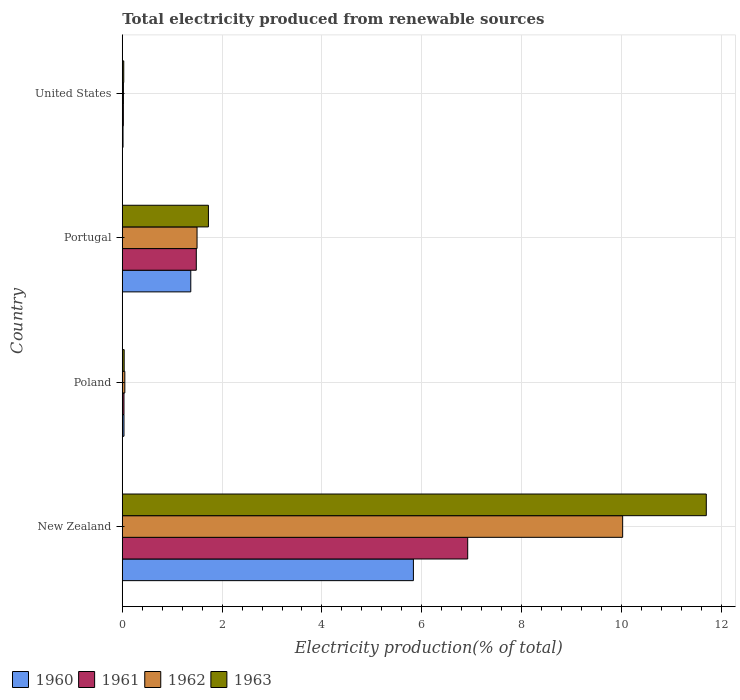How many different coloured bars are there?
Your response must be concise. 4. Are the number of bars per tick equal to the number of legend labels?
Give a very brief answer. Yes. How many bars are there on the 1st tick from the top?
Make the answer very short. 4. How many bars are there on the 1st tick from the bottom?
Your response must be concise. 4. What is the label of the 4th group of bars from the top?
Ensure brevity in your answer.  New Zealand. In how many cases, is the number of bars for a given country not equal to the number of legend labels?
Keep it short and to the point. 0. What is the total electricity produced in 1960 in Poland?
Provide a short and direct response. 0.03. Across all countries, what is the maximum total electricity produced in 1960?
Make the answer very short. 5.83. Across all countries, what is the minimum total electricity produced in 1961?
Provide a succinct answer. 0.02. In which country was the total electricity produced in 1960 maximum?
Your response must be concise. New Zealand. In which country was the total electricity produced in 1961 minimum?
Make the answer very short. United States. What is the total total electricity produced in 1963 in the graph?
Provide a succinct answer. 13.49. What is the difference between the total electricity produced in 1963 in New Zealand and that in Poland?
Your answer should be very brief. 11.66. What is the difference between the total electricity produced in 1962 in United States and the total electricity produced in 1961 in New Zealand?
Provide a succinct answer. -6.9. What is the average total electricity produced in 1962 per country?
Your response must be concise. 2.9. What is the difference between the total electricity produced in 1963 and total electricity produced in 1962 in Poland?
Provide a short and direct response. -0.01. In how many countries, is the total electricity produced in 1962 greater than 0.4 %?
Make the answer very short. 2. What is the ratio of the total electricity produced in 1961 in New Zealand to that in Poland?
Your response must be concise. 202.83. What is the difference between the highest and the second highest total electricity produced in 1960?
Offer a very short reply. 4.46. What is the difference between the highest and the lowest total electricity produced in 1960?
Your answer should be compact. 5.82. In how many countries, is the total electricity produced in 1962 greater than the average total electricity produced in 1962 taken over all countries?
Your answer should be compact. 1. Is it the case that in every country, the sum of the total electricity produced in 1960 and total electricity produced in 1962 is greater than the sum of total electricity produced in 1961 and total electricity produced in 1963?
Provide a succinct answer. No. What does the 3rd bar from the bottom in New Zealand represents?
Your response must be concise. 1962. How many bars are there?
Provide a short and direct response. 16. Are all the bars in the graph horizontal?
Offer a terse response. Yes. How many countries are there in the graph?
Provide a short and direct response. 4. Does the graph contain any zero values?
Your response must be concise. No. Where does the legend appear in the graph?
Your response must be concise. Bottom left. How many legend labels are there?
Ensure brevity in your answer.  4. How are the legend labels stacked?
Make the answer very short. Horizontal. What is the title of the graph?
Offer a very short reply. Total electricity produced from renewable sources. What is the Electricity production(% of total) in 1960 in New Zealand?
Provide a short and direct response. 5.83. What is the Electricity production(% of total) in 1961 in New Zealand?
Offer a terse response. 6.92. What is the Electricity production(% of total) of 1962 in New Zealand?
Provide a short and direct response. 10.02. What is the Electricity production(% of total) of 1963 in New Zealand?
Provide a short and direct response. 11.7. What is the Electricity production(% of total) in 1960 in Poland?
Ensure brevity in your answer.  0.03. What is the Electricity production(% of total) in 1961 in Poland?
Provide a short and direct response. 0.03. What is the Electricity production(% of total) of 1962 in Poland?
Offer a very short reply. 0.05. What is the Electricity production(% of total) of 1963 in Poland?
Your answer should be compact. 0.04. What is the Electricity production(% of total) of 1960 in Portugal?
Your response must be concise. 1.37. What is the Electricity production(% of total) of 1961 in Portugal?
Offer a terse response. 1.48. What is the Electricity production(% of total) in 1962 in Portugal?
Make the answer very short. 1.5. What is the Electricity production(% of total) of 1963 in Portugal?
Ensure brevity in your answer.  1.73. What is the Electricity production(% of total) in 1960 in United States?
Offer a terse response. 0.02. What is the Electricity production(% of total) of 1961 in United States?
Give a very brief answer. 0.02. What is the Electricity production(% of total) of 1962 in United States?
Offer a terse response. 0.02. What is the Electricity production(% of total) in 1963 in United States?
Make the answer very short. 0.03. Across all countries, what is the maximum Electricity production(% of total) of 1960?
Ensure brevity in your answer.  5.83. Across all countries, what is the maximum Electricity production(% of total) in 1961?
Your response must be concise. 6.92. Across all countries, what is the maximum Electricity production(% of total) of 1962?
Offer a very short reply. 10.02. Across all countries, what is the maximum Electricity production(% of total) in 1963?
Keep it short and to the point. 11.7. Across all countries, what is the minimum Electricity production(% of total) of 1960?
Your answer should be very brief. 0.02. Across all countries, what is the minimum Electricity production(% of total) in 1961?
Provide a short and direct response. 0.02. Across all countries, what is the minimum Electricity production(% of total) of 1962?
Give a very brief answer. 0.02. Across all countries, what is the minimum Electricity production(% of total) in 1963?
Offer a terse response. 0.03. What is the total Electricity production(% of total) of 1960 in the graph?
Your answer should be very brief. 7.25. What is the total Electricity production(% of total) of 1961 in the graph?
Your response must be concise. 8.46. What is the total Electricity production(% of total) in 1962 in the graph?
Your response must be concise. 11.6. What is the total Electricity production(% of total) in 1963 in the graph?
Provide a succinct answer. 13.49. What is the difference between the Electricity production(% of total) in 1960 in New Zealand and that in Poland?
Give a very brief answer. 5.8. What is the difference between the Electricity production(% of total) in 1961 in New Zealand and that in Poland?
Make the answer very short. 6.89. What is the difference between the Electricity production(% of total) of 1962 in New Zealand and that in Poland?
Offer a very short reply. 9.97. What is the difference between the Electricity production(% of total) of 1963 in New Zealand and that in Poland?
Keep it short and to the point. 11.66. What is the difference between the Electricity production(% of total) of 1960 in New Zealand and that in Portugal?
Your answer should be very brief. 4.46. What is the difference between the Electricity production(% of total) in 1961 in New Zealand and that in Portugal?
Keep it short and to the point. 5.44. What is the difference between the Electricity production(% of total) in 1962 in New Zealand and that in Portugal?
Keep it short and to the point. 8.53. What is the difference between the Electricity production(% of total) in 1963 in New Zealand and that in Portugal?
Offer a very short reply. 9.97. What is the difference between the Electricity production(% of total) in 1960 in New Zealand and that in United States?
Your answer should be very brief. 5.82. What is the difference between the Electricity production(% of total) in 1961 in New Zealand and that in United States?
Ensure brevity in your answer.  6.9. What is the difference between the Electricity production(% of total) in 1962 in New Zealand and that in United States?
Provide a succinct answer. 10. What is the difference between the Electricity production(% of total) in 1963 in New Zealand and that in United States?
Provide a succinct answer. 11.67. What is the difference between the Electricity production(% of total) in 1960 in Poland and that in Portugal?
Provide a succinct answer. -1.34. What is the difference between the Electricity production(% of total) of 1961 in Poland and that in Portugal?
Your answer should be compact. -1.45. What is the difference between the Electricity production(% of total) in 1962 in Poland and that in Portugal?
Give a very brief answer. -1.45. What is the difference between the Electricity production(% of total) of 1963 in Poland and that in Portugal?
Offer a very short reply. -1.69. What is the difference between the Electricity production(% of total) in 1960 in Poland and that in United States?
Ensure brevity in your answer.  0.02. What is the difference between the Electricity production(% of total) in 1961 in Poland and that in United States?
Your response must be concise. 0.01. What is the difference between the Electricity production(% of total) of 1962 in Poland and that in United States?
Your response must be concise. 0.03. What is the difference between the Electricity production(% of total) of 1963 in Poland and that in United States?
Provide a succinct answer. 0.01. What is the difference between the Electricity production(% of total) in 1960 in Portugal and that in United States?
Offer a very short reply. 1.36. What is the difference between the Electricity production(% of total) in 1961 in Portugal and that in United States?
Your answer should be compact. 1.46. What is the difference between the Electricity production(% of total) of 1962 in Portugal and that in United States?
Provide a short and direct response. 1.48. What is the difference between the Electricity production(% of total) of 1963 in Portugal and that in United States?
Keep it short and to the point. 1.7. What is the difference between the Electricity production(% of total) in 1960 in New Zealand and the Electricity production(% of total) in 1961 in Poland?
Provide a short and direct response. 5.8. What is the difference between the Electricity production(% of total) in 1960 in New Zealand and the Electricity production(% of total) in 1962 in Poland?
Give a very brief answer. 5.78. What is the difference between the Electricity production(% of total) of 1960 in New Zealand and the Electricity production(% of total) of 1963 in Poland?
Offer a very short reply. 5.79. What is the difference between the Electricity production(% of total) of 1961 in New Zealand and the Electricity production(% of total) of 1962 in Poland?
Keep it short and to the point. 6.87. What is the difference between the Electricity production(% of total) of 1961 in New Zealand and the Electricity production(% of total) of 1963 in Poland?
Your response must be concise. 6.88. What is the difference between the Electricity production(% of total) in 1962 in New Zealand and the Electricity production(% of total) in 1963 in Poland?
Your answer should be very brief. 9.99. What is the difference between the Electricity production(% of total) of 1960 in New Zealand and the Electricity production(% of total) of 1961 in Portugal?
Make the answer very short. 4.35. What is the difference between the Electricity production(% of total) in 1960 in New Zealand and the Electricity production(% of total) in 1962 in Portugal?
Make the answer very short. 4.33. What is the difference between the Electricity production(% of total) in 1960 in New Zealand and the Electricity production(% of total) in 1963 in Portugal?
Provide a succinct answer. 4.11. What is the difference between the Electricity production(% of total) of 1961 in New Zealand and the Electricity production(% of total) of 1962 in Portugal?
Give a very brief answer. 5.42. What is the difference between the Electricity production(% of total) in 1961 in New Zealand and the Electricity production(% of total) in 1963 in Portugal?
Your answer should be very brief. 5.19. What is the difference between the Electricity production(% of total) in 1962 in New Zealand and the Electricity production(% of total) in 1963 in Portugal?
Provide a succinct answer. 8.3. What is the difference between the Electricity production(% of total) of 1960 in New Zealand and the Electricity production(% of total) of 1961 in United States?
Give a very brief answer. 5.81. What is the difference between the Electricity production(% of total) in 1960 in New Zealand and the Electricity production(% of total) in 1962 in United States?
Make the answer very short. 5.81. What is the difference between the Electricity production(% of total) of 1960 in New Zealand and the Electricity production(% of total) of 1963 in United States?
Provide a succinct answer. 5.8. What is the difference between the Electricity production(% of total) in 1961 in New Zealand and the Electricity production(% of total) in 1962 in United States?
Offer a terse response. 6.9. What is the difference between the Electricity production(% of total) of 1961 in New Zealand and the Electricity production(% of total) of 1963 in United States?
Offer a terse response. 6.89. What is the difference between the Electricity production(% of total) in 1962 in New Zealand and the Electricity production(% of total) in 1963 in United States?
Give a very brief answer. 10. What is the difference between the Electricity production(% of total) in 1960 in Poland and the Electricity production(% of total) in 1961 in Portugal?
Make the answer very short. -1.45. What is the difference between the Electricity production(% of total) of 1960 in Poland and the Electricity production(% of total) of 1962 in Portugal?
Provide a short and direct response. -1.46. What is the difference between the Electricity production(% of total) in 1960 in Poland and the Electricity production(% of total) in 1963 in Portugal?
Keep it short and to the point. -1.69. What is the difference between the Electricity production(% of total) of 1961 in Poland and the Electricity production(% of total) of 1962 in Portugal?
Offer a terse response. -1.46. What is the difference between the Electricity production(% of total) of 1961 in Poland and the Electricity production(% of total) of 1963 in Portugal?
Your response must be concise. -1.69. What is the difference between the Electricity production(% of total) of 1962 in Poland and the Electricity production(% of total) of 1963 in Portugal?
Offer a very short reply. -1.67. What is the difference between the Electricity production(% of total) of 1960 in Poland and the Electricity production(% of total) of 1961 in United States?
Offer a very short reply. 0.01. What is the difference between the Electricity production(% of total) in 1960 in Poland and the Electricity production(% of total) in 1962 in United States?
Give a very brief answer. 0.01. What is the difference between the Electricity production(% of total) of 1960 in Poland and the Electricity production(% of total) of 1963 in United States?
Offer a terse response. 0. What is the difference between the Electricity production(% of total) of 1961 in Poland and the Electricity production(% of total) of 1962 in United States?
Provide a short and direct response. 0.01. What is the difference between the Electricity production(% of total) in 1961 in Poland and the Electricity production(% of total) in 1963 in United States?
Keep it short and to the point. 0. What is the difference between the Electricity production(% of total) in 1962 in Poland and the Electricity production(% of total) in 1963 in United States?
Your answer should be compact. 0.02. What is the difference between the Electricity production(% of total) of 1960 in Portugal and the Electricity production(% of total) of 1961 in United States?
Offer a very short reply. 1.35. What is the difference between the Electricity production(% of total) of 1960 in Portugal and the Electricity production(% of total) of 1962 in United States?
Keep it short and to the point. 1.35. What is the difference between the Electricity production(% of total) of 1960 in Portugal and the Electricity production(% of total) of 1963 in United States?
Provide a succinct answer. 1.34. What is the difference between the Electricity production(% of total) in 1961 in Portugal and the Electricity production(% of total) in 1962 in United States?
Provide a short and direct response. 1.46. What is the difference between the Electricity production(% of total) in 1961 in Portugal and the Electricity production(% of total) in 1963 in United States?
Your response must be concise. 1.45. What is the difference between the Electricity production(% of total) of 1962 in Portugal and the Electricity production(% of total) of 1963 in United States?
Make the answer very short. 1.47. What is the average Electricity production(% of total) of 1960 per country?
Your answer should be very brief. 1.81. What is the average Electricity production(% of total) in 1961 per country?
Make the answer very short. 2.11. What is the average Electricity production(% of total) in 1962 per country?
Provide a short and direct response. 2.9. What is the average Electricity production(% of total) in 1963 per country?
Provide a succinct answer. 3.37. What is the difference between the Electricity production(% of total) of 1960 and Electricity production(% of total) of 1961 in New Zealand?
Provide a succinct answer. -1.09. What is the difference between the Electricity production(% of total) in 1960 and Electricity production(% of total) in 1962 in New Zealand?
Offer a terse response. -4.19. What is the difference between the Electricity production(% of total) of 1960 and Electricity production(% of total) of 1963 in New Zealand?
Give a very brief answer. -5.87. What is the difference between the Electricity production(% of total) in 1961 and Electricity production(% of total) in 1962 in New Zealand?
Your response must be concise. -3.1. What is the difference between the Electricity production(% of total) of 1961 and Electricity production(% of total) of 1963 in New Zealand?
Offer a terse response. -4.78. What is the difference between the Electricity production(% of total) of 1962 and Electricity production(% of total) of 1963 in New Zealand?
Provide a succinct answer. -1.68. What is the difference between the Electricity production(% of total) of 1960 and Electricity production(% of total) of 1962 in Poland?
Make the answer very short. -0.02. What is the difference between the Electricity production(% of total) in 1960 and Electricity production(% of total) in 1963 in Poland?
Keep it short and to the point. -0. What is the difference between the Electricity production(% of total) in 1961 and Electricity production(% of total) in 1962 in Poland?
Provide a succinct answer. -0.02. What is the difference between the Electricity production(% of total) of 1961 and Electricity production(% of total) of 1963 in Poland?
Your answer should be very brief. -0. What is the difference between the Electricity production(% of total) of 1962 and Electricity production(% of total) of 1963 in Poland?
Offer a terse response. 0.01. What is the difference between the Electricity production(% of total) in 1960 and Electricity production(% of total) in 1961 in Portugal?
Offer a very short reply. -0.11. What is the difference between the Electricity production(% of total) in 1960 and Electricity production(% of total) in 1962 in Portugal?
Provide a short and direct response. -0.13. What is the difference between the Electricity production(% of total) of 1960 and Electricity production(% of total) of 1963 in Portugal?
Your answer should be compact. -0.35. What is the difference between the Electricity production(% of total) of 1961 and Electricity production(% of total) of 1962 in Portugal?
Offer a very short reply. -0.02. What is the difference between the Electricity production(% of total) in 1961 and Electricity production(% of total) in 1963 in Portugal?
Make the answer very short. -0.24. What is the difference between the Electricity production(% of total) of 1962 and Electricity production(% of total) of 1963 in Portugal?
Provide a succinct answer. -0.23. What is the difference between the Electricity production(% of total) of 1960 and Electricity production(% of total) of 1961 in United States?
Provide a succinct answer. -0.01. What is the difference between the Electricity production(% of total) in 1960 and Electricity production(% of total) in 1962 in United States?
Your answer should be compact. -0.01. What is the difference between the Electricity production(% of total) of 1960 and Electricity production(% of total) of 1963 in United States?
Your answer should be compact. -0.01. What is the difference between the Electricity production(% of total) of 1961 and Electricity production(% of total) of 1962 in United States?
Your answer should be compact. -0. What is the difference between the Electricity production(% of total) of 1961 and Electricity production(% of total) of 1963 in United States?
Keep it short and to the point. -0.01. What is the difference between the Electricity production(% of total) in 1962 and Electricity production(% of total) in 1963 in United States?
Keep it short and to the point. -0.01. What is the ratio of the Electricity production(% of total) in 1960 in New Zealand to that in Poland?
Make the answer very short. 170.79. What is the ratio of the Electricity production(% of total) in 1961 in New Zealand to that in Poland?
Give a very brief answer. 202.83. What is the ratio of the Electricity production(% of total) in 1962 in New Zealand to that in Poland?
Ensure brevity in your answer.  196.95. What is the ratio of the Electricity production(% of total) in 1963 in New Zealand to that in Poland?
Your answer should be very brief. 308.73. What is the ratio of the Electricity production(% of total) of 1960 in New Zealand to that in Portugal?
Keep it short and to the point. 4.25. What is the ratio of the Electricity production(% of total) in 1961 in New Zealand to that in Portugal?
Offer a terse response. 4.67. What is the ratio of the Electricity production(% of total) of 1962 in New Zealand to that in Portugal?
Your answer should be very brief. 6.69. What is the ratio of the Electricity production(% of total) in 1963 in New Zealand to that in Portugal?
Ensure brevity in your answer.  6.78. What is the ratio of the Electricity production(% of total) in 1960 in New Zealand to that in United States?
Ensure brevity in your answer.  382.31. What is the ratio of the Electricity production(% of total) of 1961 in New Zealand to that in United States?
Keep it short and to the point. 321.25. What is the ratio of the Electricity production(% of total) of 1962 in New Zealand to that in United States?
Offer a very short reply. 439.93. What is the ratio of the Electricity production(% of total) in 1963 in New Zealand to that in United States?
Give a very brief answer. 397.5. What is the ratio of the Electricity production(% of total) of 1960 in Poland to that in Portugal?
Your answer should be compact. 0.02. What is the ratio of the Electricity production(% of total) in 1961 in Poland to that in Portugal?
Ensure brevity in your answer.  0.02. What is the ratio of the Electricity production(% of total) of 1962 in Poland to that in Portugal?
Provide a succinct answer. 0.03. What is the ratio of the Electricity production(% of total) in 1963 in Poland to that in Portugal?
Offer a terse response. 0.02. What is the ratio of the Electricity production(% of total) of 1960 in Poland to that in United States?
Provide a short and direct response. 2.24. What is the ratio of the Electricity production(% of total) of 1961 in Poland to that in United States?
Ensure brevity in your answer.  1.58. What is the ratio of the Electricity production(% of total) of 1962 in Poland to that in United States?
Ensure brevity in your answer.  2.23. What is the ratio of the Electricity production(% of total) of 1963 in Poland to that in United States?
Your response must be concise. 1.29. What is the ratio of the Electricity production(% of total) of 1960 in Portugal to that in United States?
Provide a short and direct response. 89.96. What is the ratio of the Electricity production(% of total) of 1961 in Portugal to that in United States?
Your answer should be compact. 68.83. What is the ratio of the Electricity production(% of total) of 1962 in Portugal to that in United States?
Provide a short and direct response. 65.74. What is the ratio of the Electricity production(% of total) in 1963 in Portugal to that in United States?
Make the answer very short. 58.63. What is the difference between the highest and the second highest Electricity production(% of total) of 1960?
Provide a succinct answer. 4.46. What is the difference between the highest and the second highest Electricity production(% of total) in 1961?
Give a very brief answer. 5.44. What is the difference between the highest and the second highest Electricity production(% of total) of 1962?
Keep it short and to the point. 8.53. What is the difference between the highest and the second highest Electricity production(% of total) of 1963?
Your answer should be compact. 9.97. What is the difference between the highest and the lowest Electricity production(% of total) of 1960?
Keep it short and to the point. 5.82. What is the difference between the highest and the lowest Electricity production(% of total) of 1961?
Offer a terse response. 6.9. What is the difference between the highest and the lowest Electricity production(% of total) in 1962?
Keep it short and to the point. 10. What is the difference between the highest and the lowest Electricity production(% of total) of 1963?
Keep it short and to the point. 11.67. 